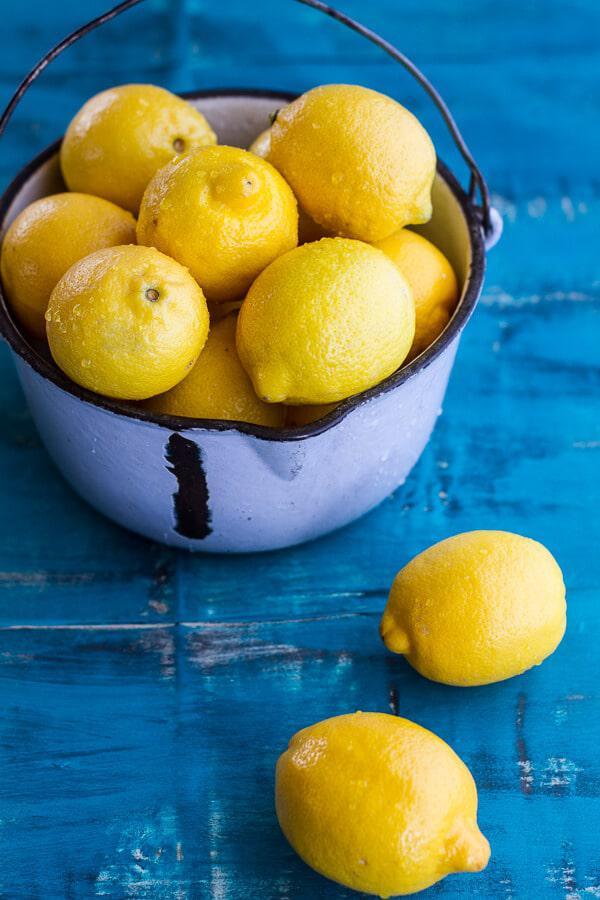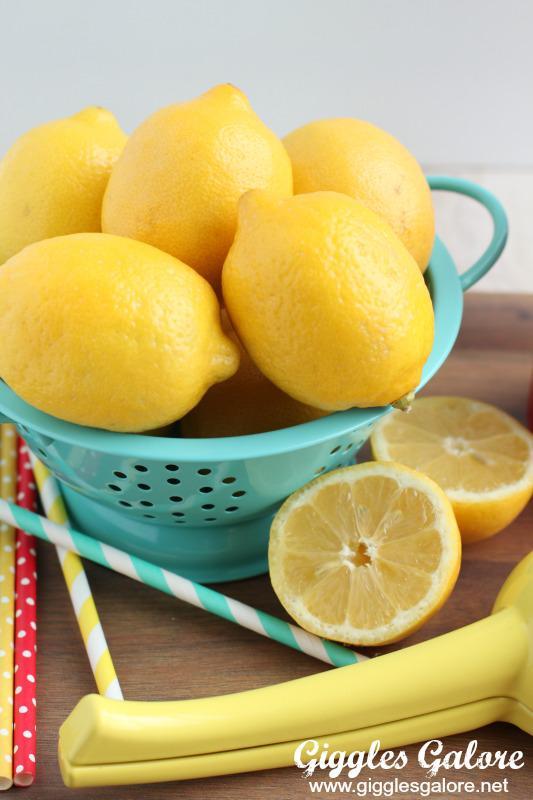The first image is the image on the left, the second image is the image on the right. Examine the images to the left and right. Is the description "Watermelon slices are pictured with lemons." accurate? Answer yes or no. No. The first image is the image on the left, the second image is the image on the right. Examine the images to the left and right. Is the description "An image shows glasses garnished with green leaves and watermelon slices." accurate? Answer yes or no. No. 